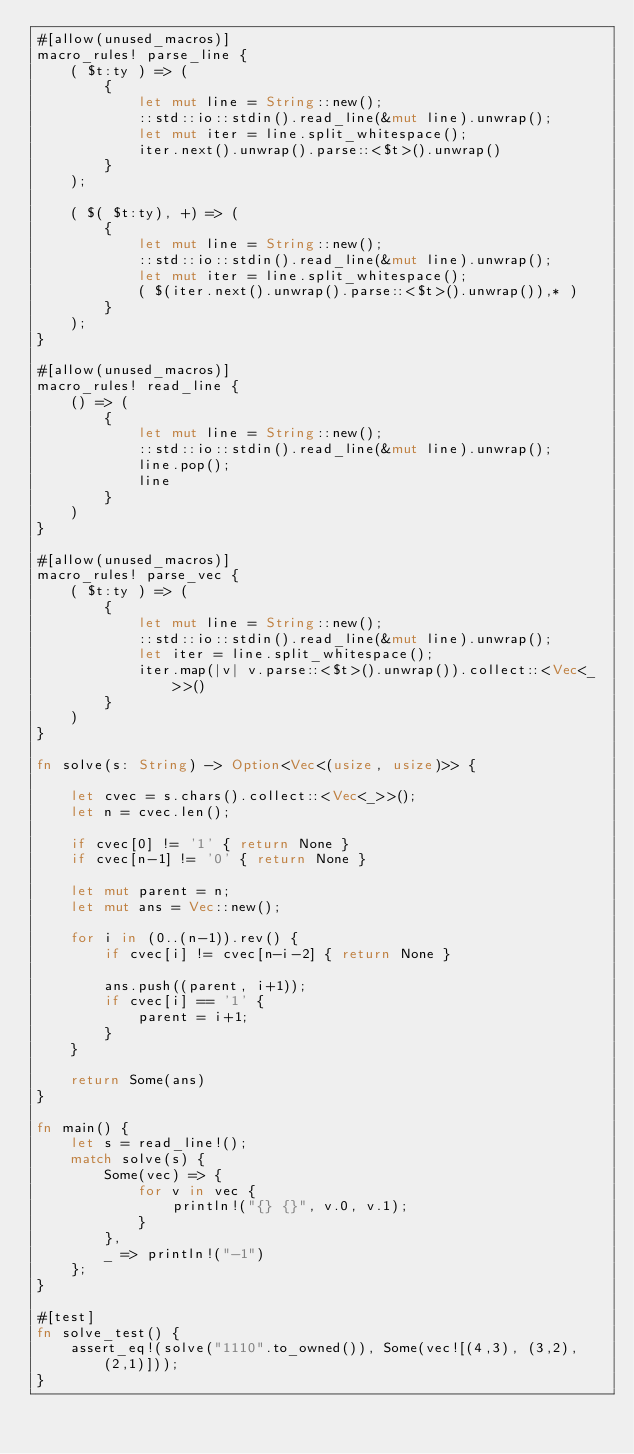Convert code to text. <code><loc_0><loc_0><loc_500><loc_500><_Rust_>#[allow(unused_macros)]
macro_rules! parse_line {
    ( $t:ty ) => (
        {
            let mut line = String::new();
            ::std::io::stdin().read_line(&mut line).unwrap();
            let mut iter = line.split_whitespace();
            iter.next().unwrap().parse::<$t>().unwrap()
        }
    );

    ( $( $t:ty), +) => (
        {
            let mut line = String::new();
            ::std::io::stdin().read_line(&mut line).unwrap();
            let mut iter = line.split_whitespace();
            ( $(iter.next().unwrap().parse::<$t>().unwrap()),* )
        }
    );
}

#[allow(unused_macros)]
macro_rules! read_line {
    () => (
        {
            let mut line = String::new();
            ::std::io::stdin().read_line(&mut line).unwrap();
            line.pop();
            line
        }
    )
}

#[allow(unused_macros)]
macro_rules! parse_vec {
    ( $t:ty ) => (
        {
            let mut line = String::new();
            ::std::io::stdin().read_line(&mut line).unwrap();
            let iter = line.split_whitespace();
            iter.map(|v| v.parse::<$t>().unwrap()).collect::<Vec<_>>()
        }
    )
}

fn solve(s: String) -> Option<Vec<(usize, usize)>> {

    let cvec = s.chars().collect::<Vec<_>>();
    let n = cvec.len();

    if cvec[0] != '1' { return None }
    if cvec[n-1] != '0' { return None }

    let mut parent = n;
    let mut ans = Vec::new();

    for i in (0..(n-1)).rev() {
        if cvec[i] != cvec[n-i-2] { return None }

        ans.push((parent, i+1));
        if cvec[i] == '1' {
            parent = i+1;
        }
    }

    return Some(ans)
}

fn main() {
    let s = read_line!();
    match solve(s) {
        Some(vec) => {
            for v in vec {
                println!("{} {}", v.0, v.1);
            }
        },
        _ => println!("-1")
    };
}

#[test]
fn solve_test() {
    assert_eq!(solve("1110".to_owned()), Some(vec![(4,3), (3,2), (2,1)]));
}
</code> 